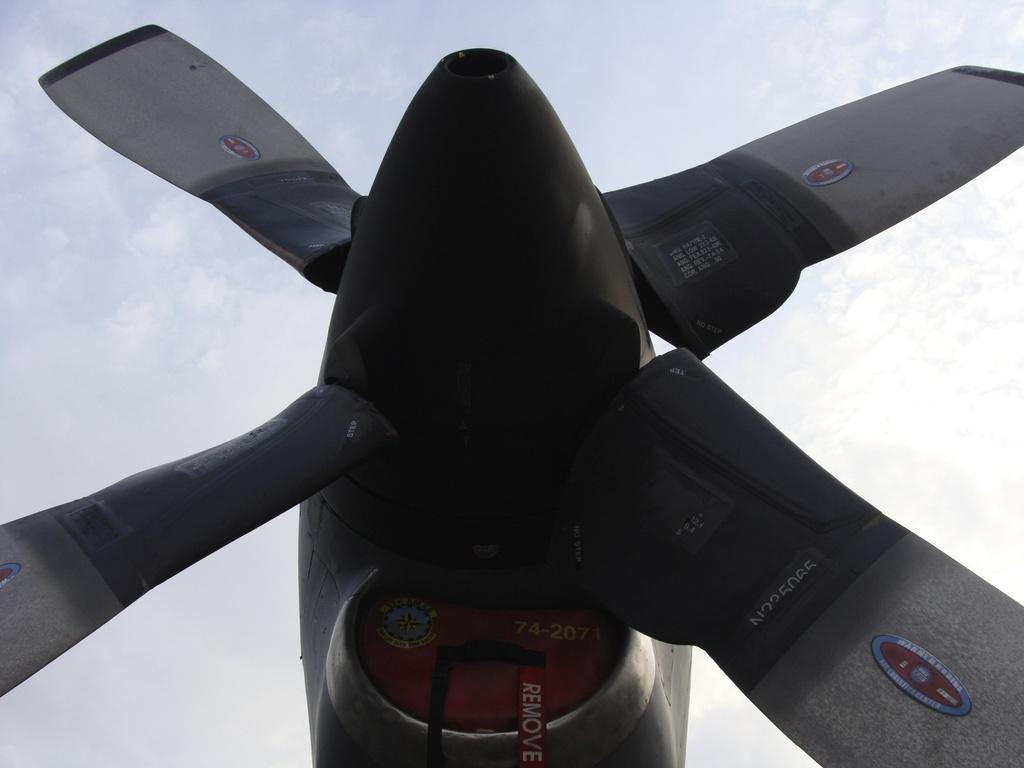In one or two sentences, can you explain what this image depicts? In this picture I can see an airplane propeller, and in the background there is the sky. 